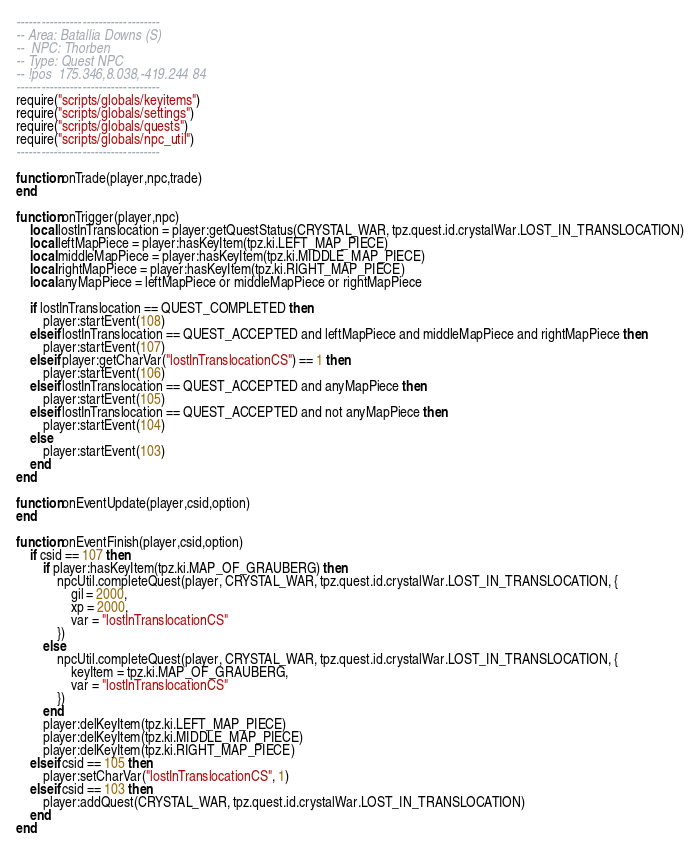Convert code to text. <code><loc_0><loc_0><loc_500><loc_500><_Lua_>-----------------------------------
-- Area: Batallia Downs (S)
--  NPC: Thorben
-- Type: Quest NPC
-- !pos  175.346,8.038,-419.244 84
-----------------------------------
require("scripts/globals/keyitems")
require("scripts/globals/settings")
require("scripts/globals/quests")
require("scripts/globals/npc_util")
-----------------------------------

function onTrade(player,npc,trade)
end

function onTrigger(player,npc)
    local lostInTranslocation = player:getQuestStatus(CRYSTAL_WAR, tpz.quest.id.crystalWar.LOST_IN_TRANSLOCATION)
    local leftMapPiece = player:hasKeyItem(tpz.ki.LEFT_MAP_PIECE)
    local middleMapPiece = player:hasKeyItem(tpz.ki.MIDDLE_MAP_PIECE)
    local rightMapPiece = player:hasKeyItem(tpz.ki.RIGHT_MAP_PIECE)
    local anyMapPiece = leftMapPiece or middleMapPiece or rightMapPiece

    if lostInTranslocation == QUEST_COMPLETED then
        player:startEvent(108)
    elseif lostInTranslocation == QUEST_ACCEPTED and leftMapPiece and middleMapPiece and rightMapPiece then
        player:startEvent(107)
    elseif player:getCharVar("lostInTranslocationCS") == 1 then
        player:startEvent(106)
    elseif lostInTranslocation == QUEST_ACCEPTED and anyMapPiece then
        player:startEvent(105)
    elseif lostInTranslocation == QUEST_ACCEPTED and not anyMapPiece then
        player:startEvent(104)
    else
        player:startEvent(103)
    end
end

function onEventUpdate(player,csid,option)
end

function onEventFinish(player,csid,option)
    if csid == 107 then
        if player:hasKeyItem(tpz.ki.MAP_OF_GRAUBERG) then
            npcUtil.completeQuest(player, CRYSTAL_WAR, tpz.quest.id.crystalWar.LOST_IN_TRANSLOCATION, {
                gil = 2000,
                xp = 2000,
                var = "lostInTranslocationCS"
            })
        else
            npcUtil.completeQuest(player, CRYSTAL_WAR, tpz.quest.id.crystalWar.LOST_IN_TRANSLOCATION, {
                keyItem = tpz.ki.MAP_OF_GRAUBERG,
                var = "lostInTranslocationCS"
            })
        end
        player:delKeyItem(tpz.ki.LEFT_MAP_PIECE)
        player:delKeyItem(tpz.ki.MIDDLE_MAP_PIECE)
        player:delKeyItem(tpz.ki.RIGHT_MAP_PIECE)
    elseif csid == 105 then
        player:setCharVar("lostInTranslocationCS", 1)
    elseif csid == 103 then
        player:addQuest(CRYSTAL_WAR, tpz.quest.id.crystalWar.LOST_IN_TRANSLOCATION)
    end
end</code> 